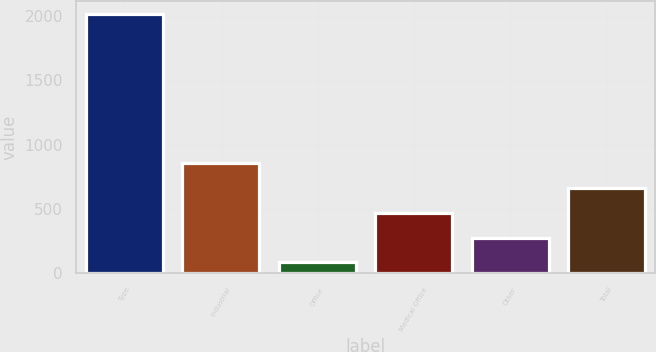Convert chart. <chart><loc_0><loc_0><loc_500><loc_500><bar_chart><fcel>Type<fcel>Industrial<fcel>Office<fcel>Medical Office<fcel>Other<fcel>Total<nl><fcel>2012<fcel>855.38<fcel>84.3<fcel>469.84<fcel>277.07<fcel>662.61<nl></chart> 